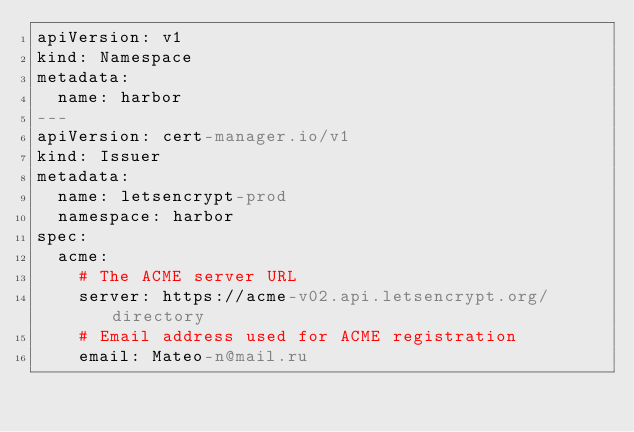<code> <loc_0><loc_0><loc_500><loc_500><_YAML_>apiVersion: v1
kind: Namespace
metadata:
  name: harbor
---
apiVersion: cert-manager.io/v1
kind: Issuer
metadata:
  name: letsencrypt-prod
  namespace: harbor
spec:
  acme:
    # The ACME server URL
    server: https://acme-v02.api.letsencrypt.org/directory
    # Email address used for ACME registration
    email: Mateo-n@mail.ru</code> 